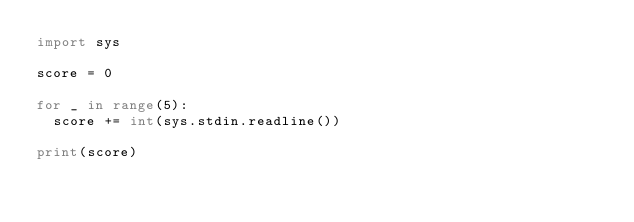Convert code to text. <code><loc_0><loc_0><loc_500><loc_500><_Python_>import sys

score = 0

for _ in range(5):
  score += int(sys.stdin.readline())

print(score)
</code> 